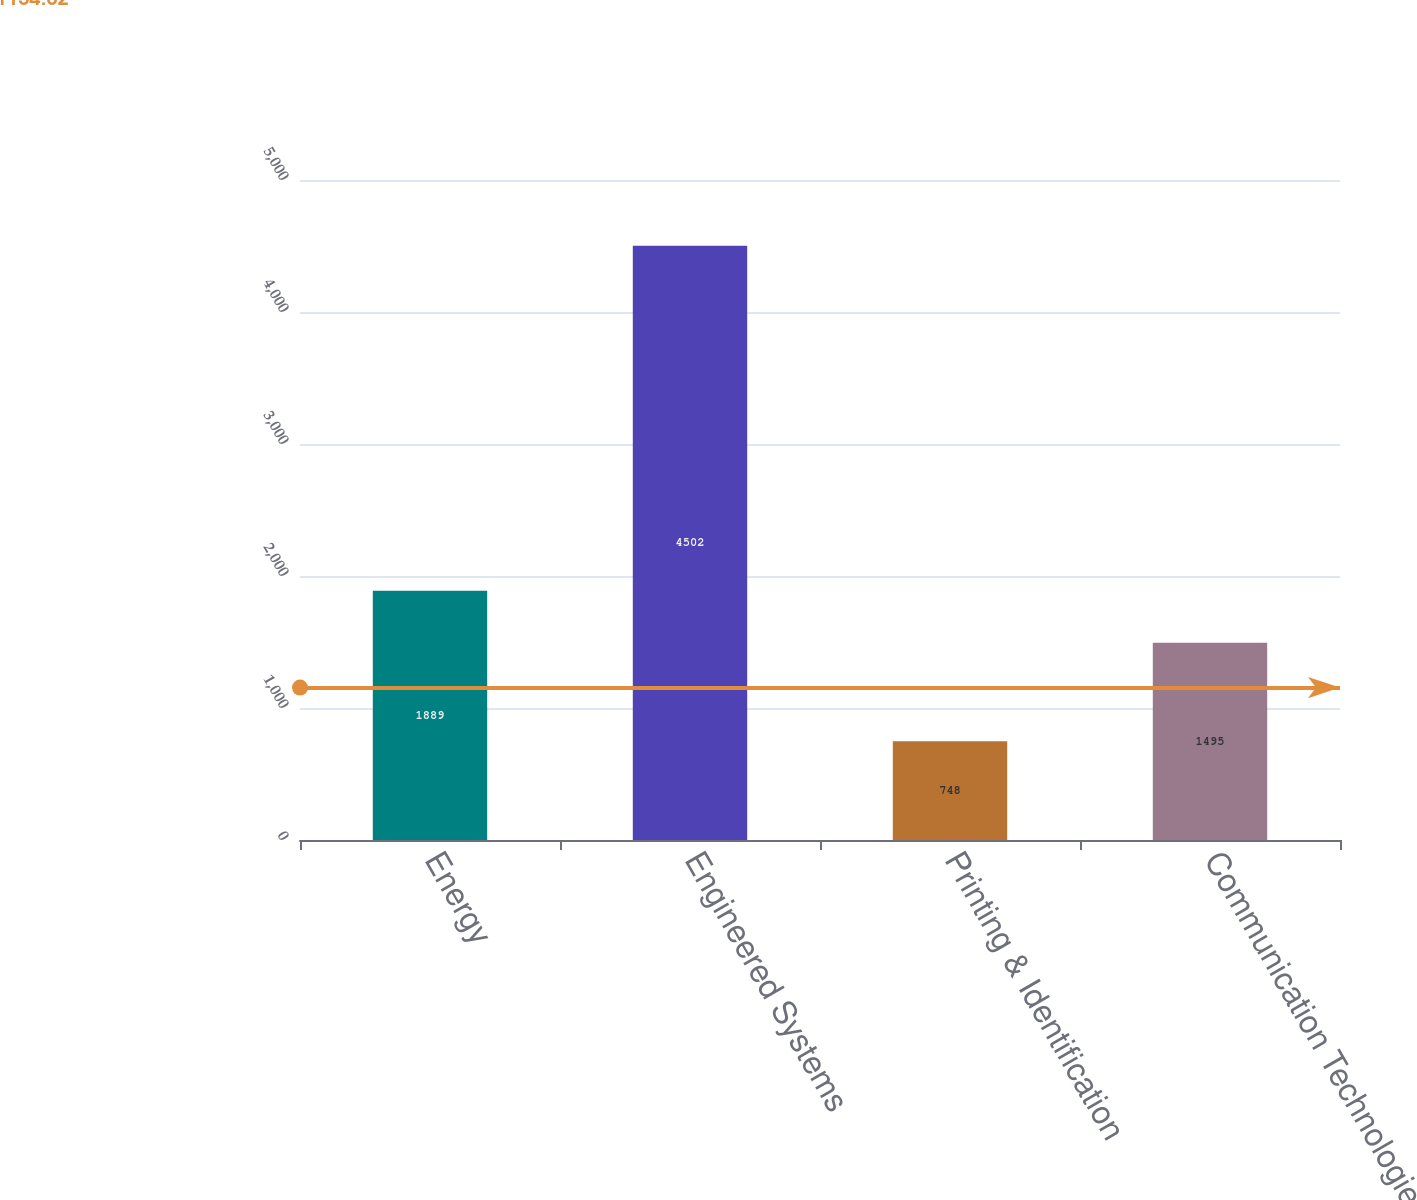Convert chart. <chart><loc_0><loc_0><loc_500><loc_500><bar_chart><fcel>Energy<fcel>Engineered Systems<fcel>Printing & Identification<fcel>Communication Technologies<nl><fcel>1889<fcel>4502<fcel>748<fcel>1495<nl></chart> 